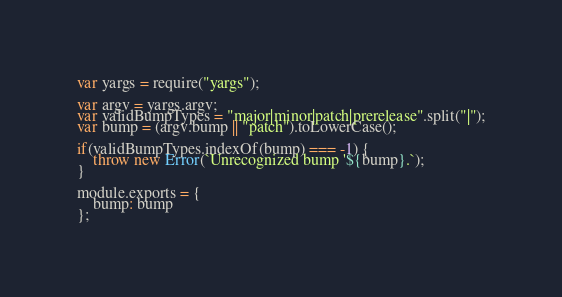Convert code to text. <code><loc_0><loc_0><loc_500><loc_500><_JavaScript_>var yargs = require("yargs");

var argv = yargs.argv;
var validBumpTypes = "major|minor|patch|prerelease".split("|");
var bump = (argv.bump || "patch").toLowerCase();

if(validBumpTypes.indexOf(bump) === -1) {
	throw new Error(`Unrecognized bump '${bump}.`);
}

module.exports = {
	bump: bump
};</code> 